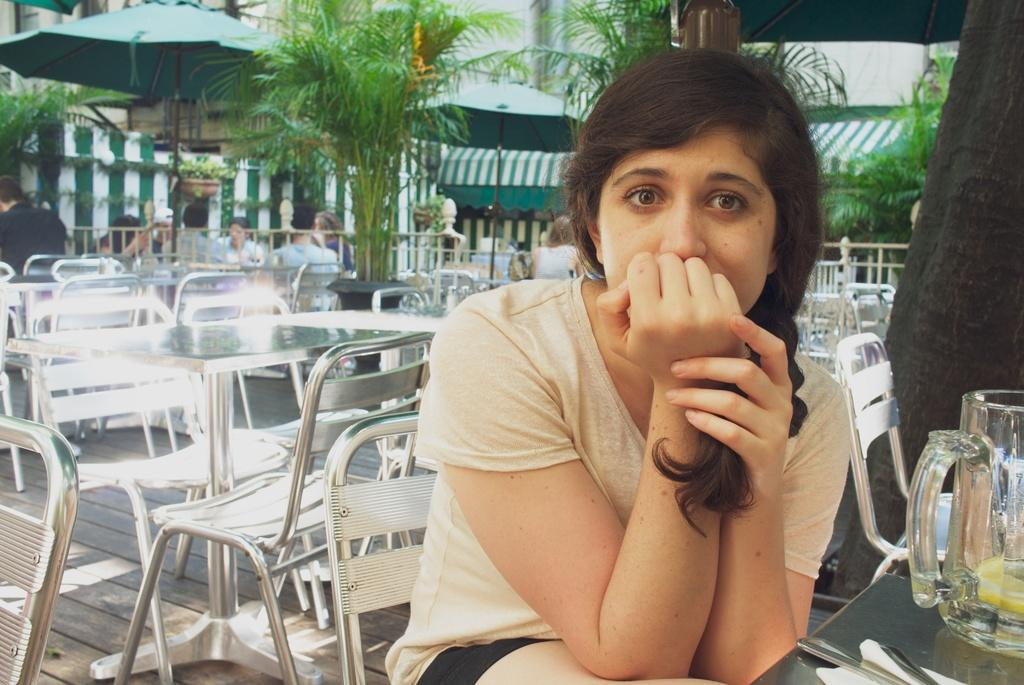What is the woman in the image doing? The woman is sitting on a chair in the image. Can you describe the other people in the image? There is a group of people in the image. What can be seen in the background of the image? There are plants and a tent in the background of the image. What type of pencil is the zebra holding in the image? There is no zebra or pencil present in the image. 